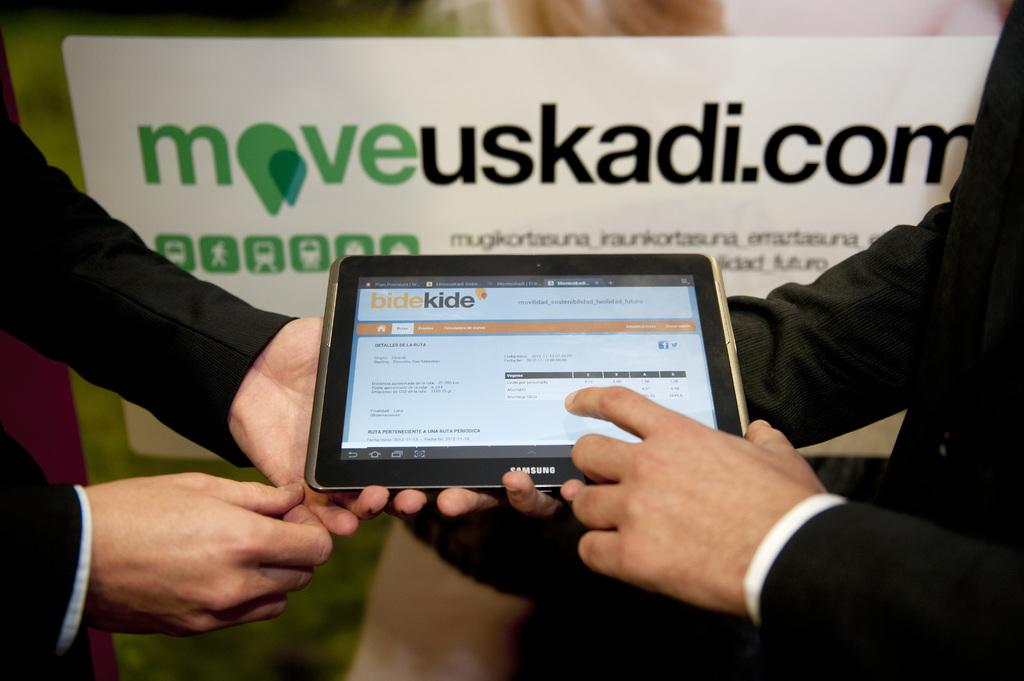What object can be seen in the image? There is a gadget in the image. What part of the human body is visible in the image? Human hands are visible in the image. What type of surface is present in the background of the image? There is a whiteboard with text in the background of the image. How many rifles can be seen in the image? There are no rifles present in the image. What type of grip is being used to hold the gadget in the image? The image does not show any specific grip being used to hold the gadget, as only the hands are visible. 